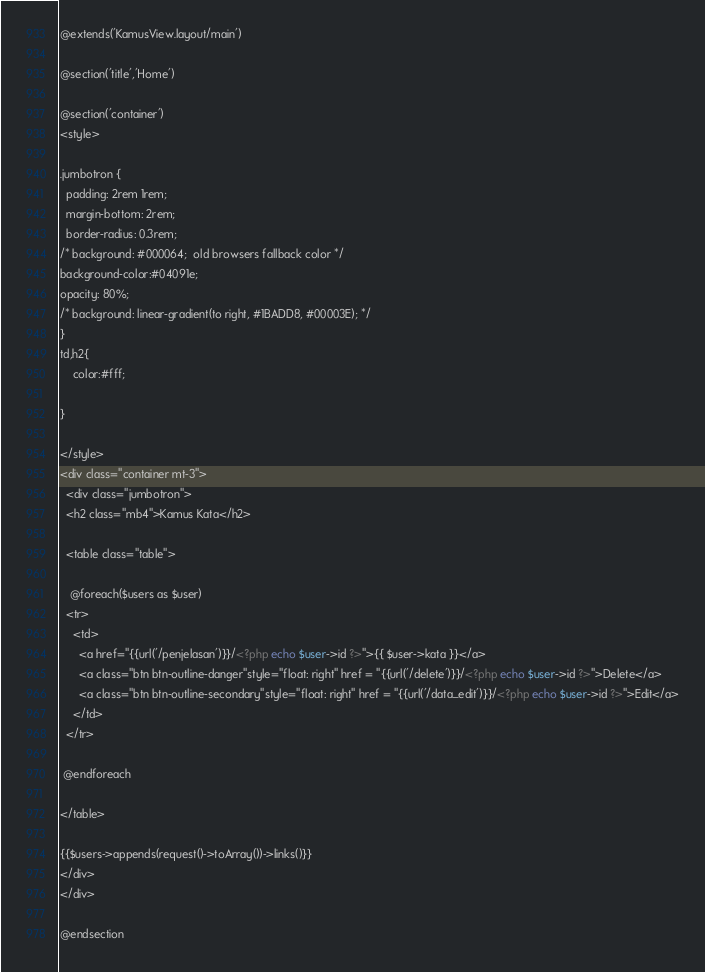Convert code to text. <code><loc_0><loc_0><loc_500><loc_500><_PHP_>@extends('KamusView.layout/main')

@section('title','Home')

@section('container')
<style>
 
.jumbotron {
  padding: 2rem 1rem;
  margin-bottom: 2rem;
  border-radius: 0.3rem;
/* background: #000064;  old browsers fallback color */
background-color:#04091e; 
opacity: 80%;
/* background: linear-gradient(to right, #1BADD8, #00003E); */
}
td,h2{
    color:#fff;

}
 
</style>
<div class="container mt-3">
  <div class="jumbotron">
  <h2 class="mb4">Kamus Kata</h2>

  <table class="table">

   @foreach($users as $user)
  <tr>
    <td>
      <a href="{{url('/penjelasan')}}/<?php echo $user->id ?>">{{ $user->kata }}</a>
      <a class="btn btn-outline-danger"style="float: right" href = "{{url('/delete')}}/<?php echo $user->id ?>">Delete</a>
      <a class="btn btn-outline-secondary"style="float: right" href = "{{url('/data_edit')}}/<?php echo $user->id ?>">Edit</a>
    </td>  
  </tr>

 @endforeach

</table>

{{$users->appends(request()->toArray())->links()}}
</div>
</div>

@endsection</code> 